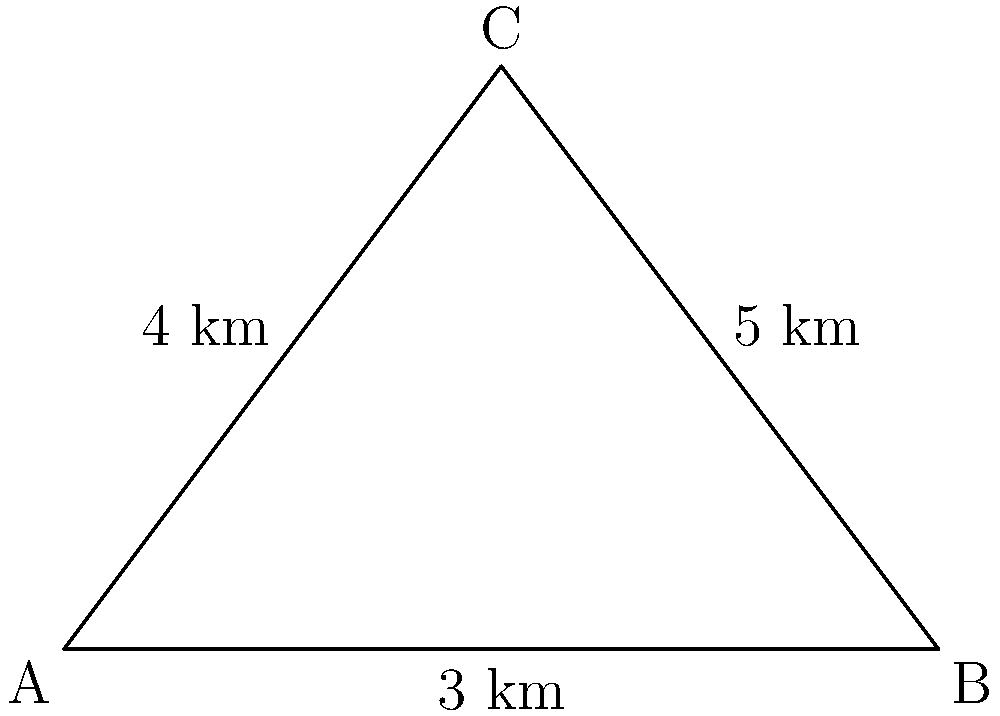A critical triangular region on a topographical map is defined by three landmarks: A, B, and C. The distances between these points are as follows: AB = 3 km, AC = 4 km, and BC = 5 km. Calculate the area of this triangular region in square kilometers. Round your answer to two decimal places. To solve this problem, we can use Heron's formula for the area of a triangle given the lengths of its sides.

Step 1: Recall Heron's formula:
Area = $\sqrt{s(s-a)(s-b)(s-c)}$
where $s$ is the semi-perimeter, and $a$, $b$, and $c$ are the side lengths.

Step 2: Calculate the semi-perimeter $s$:
$s = \frac{a + b + c}{2} = \frac{3 + 4 + 5}{2} = \frac{12}{2} = 6$ km

Step 3: Apply Heron's formula:
Area = $\sqrt{6(6-3)(6-4)(6-5)}$
    = $\sqrt{6 \cdot 3 \cdot 2 \cdot 1}$
    = $\sqrt{36}$
    = 6 km²

Step 4: Round to two decimal places:
6.00 km²

This area calculation is crucial for assessing the size of the region of interest and planning field operations accordingly.
Answer: 6.00 km² 